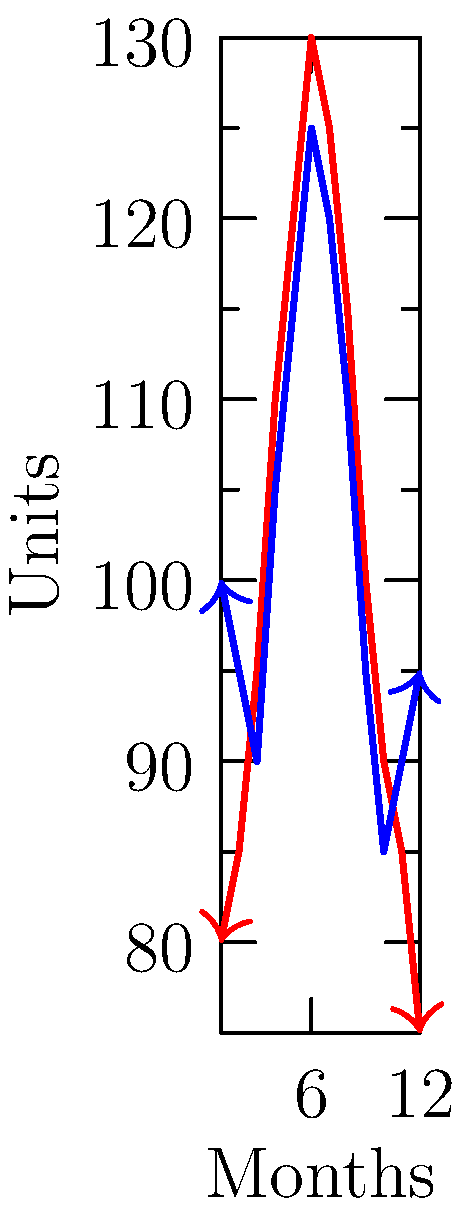The graph shows the seasonal demand fluctuations and inventory levels for a food processing company over a 12-month period. Calculate the dot product of the demand vector $\mathbf{d}$ and the inventory vector $\mathbf{i}$. What does this value represent in the context of supply chain optimization? To solve this problem, we'll follow these steps:

1) First, let's identify our vectors:
   $\mathbf{d} = (80,85,95,110,120,130,125,115,100,90,85,75)$
   $\mathbf{i} = (100,95,90,105,115,125,120,110,95,85,90,95)$

2) The dot product of two vectors $\mathbf{a} = (a_1, ..., a_n)$ and $\mathbf{b} = (b_1, ..., b_n)$ is defined as:
   $\mathbf{a} \cdot \mathbf{b} = \sum_{i=1}^n a_i b_i$

3) Let's calculate this sum:
   $\mathbf{d} \cdot \mathbf{i} = (80 \times 100) + (85 \times 95) + (95 \times 90) + ... + (75 \times 95)$

4) Performing the calculation:
   $\mathbf{d} \cdot \mathbf{i} = 8000 + 8075 + 8550 + 11550 + 13800 + 16250 + 15000 + 12650 + 9500 + 7650 + 7650 + 7125 = 125,800$

5) In the context of supply chain optimization, this dot product represents the total alignment between demand and inventory over the year. A higher value indicates that inventory levels are generally high when demand is high, and low when demand is low, which is desirable for efficient inventory management.

6) However, to get a normalized measure of alignment, we should consider the magnitudes of the vectors. This would involve dividing the dot product by the product of the magnitudes of the two vectors, giving us the cosine of the angle between the vectors.
Answer: 125,800; represents total demand-inventory alignment 